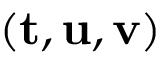Convert formula to latex. <formula><loc_0><loc_0><loc_500><loc_500>( { t } , { u } , { v } )</formula> 